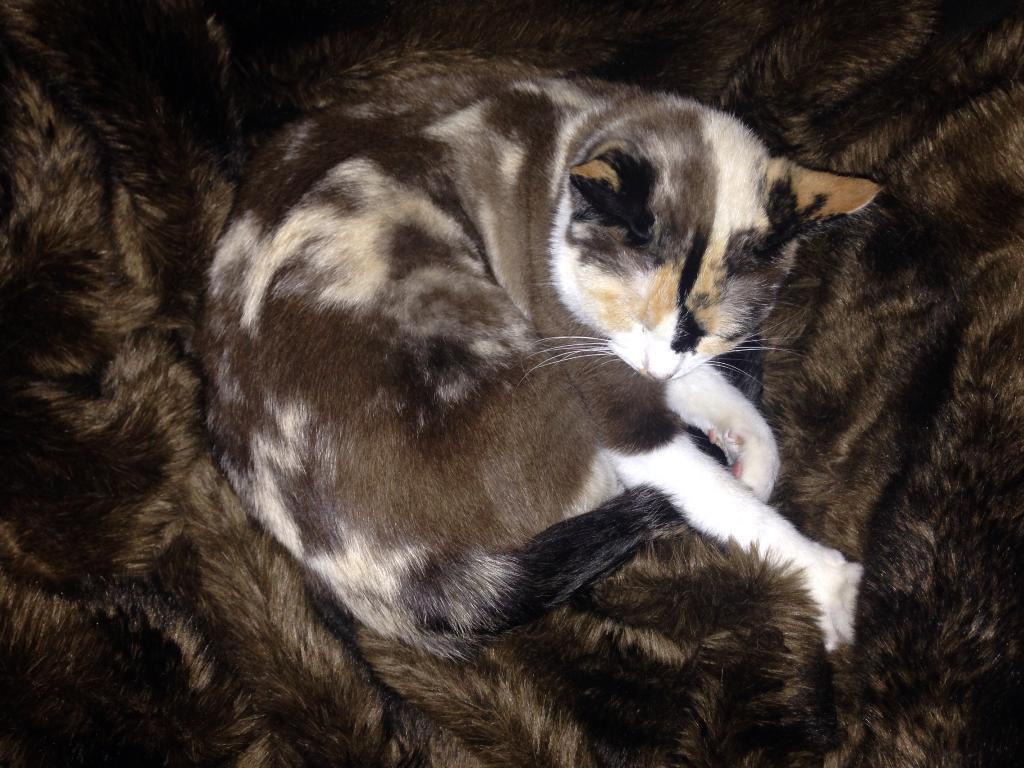Could you give a brief overview of what you see in this image? A cat is sleeping, it is in black and white color. 